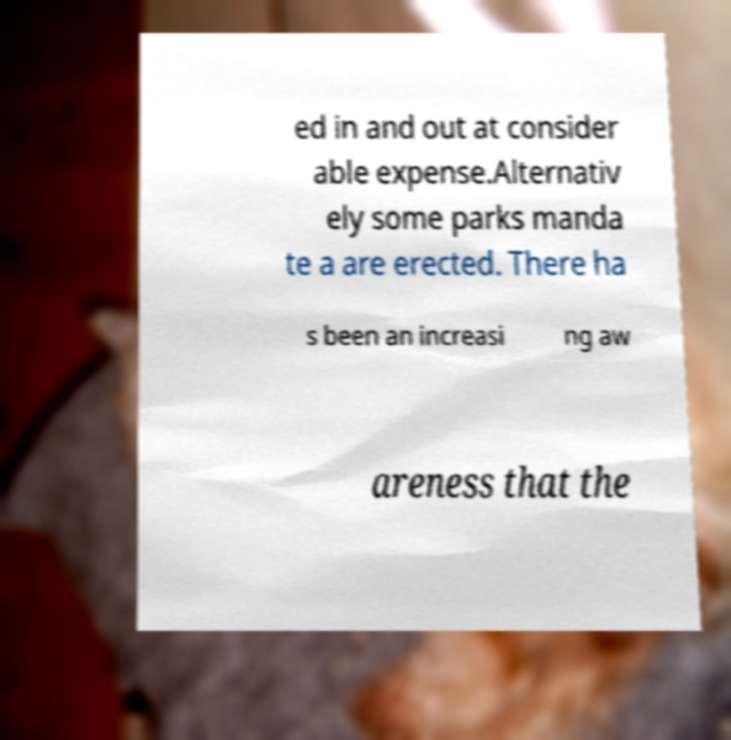Please read and relay the text visible in this image. What does it say? ed in and out at consider able expense.Alternativ ely some parks manda te a are erected. There ha s been an increasi ng aw areness that the 